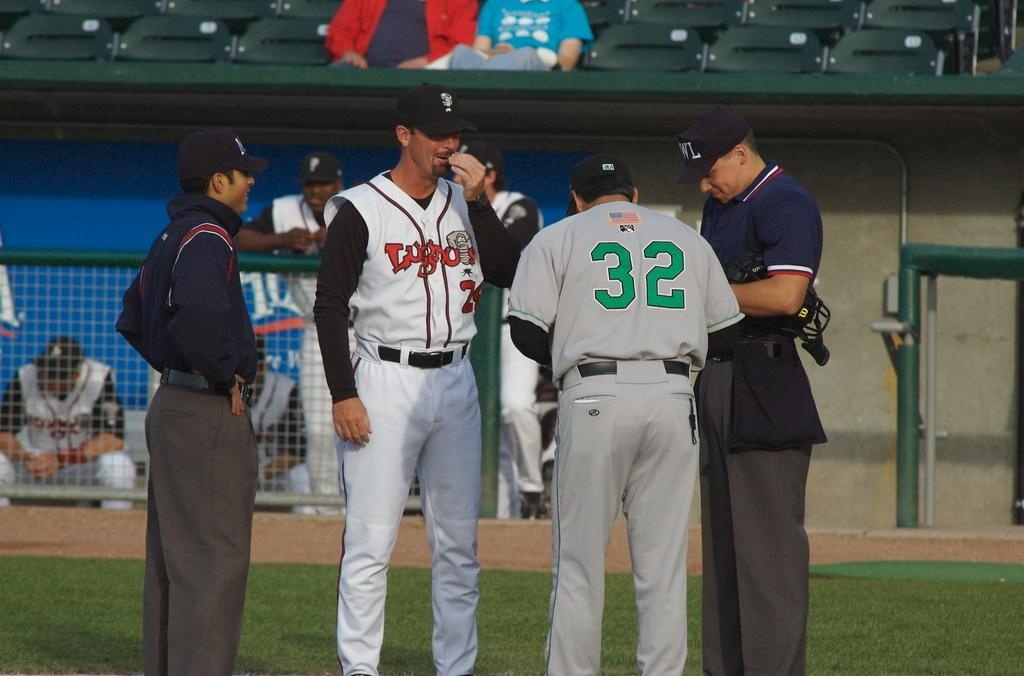<image>
Present a compact description of the photo's key features. Two players, wearing a jersey with the number 32 on the back, from opposing baseball teams in a discussion with umpires 